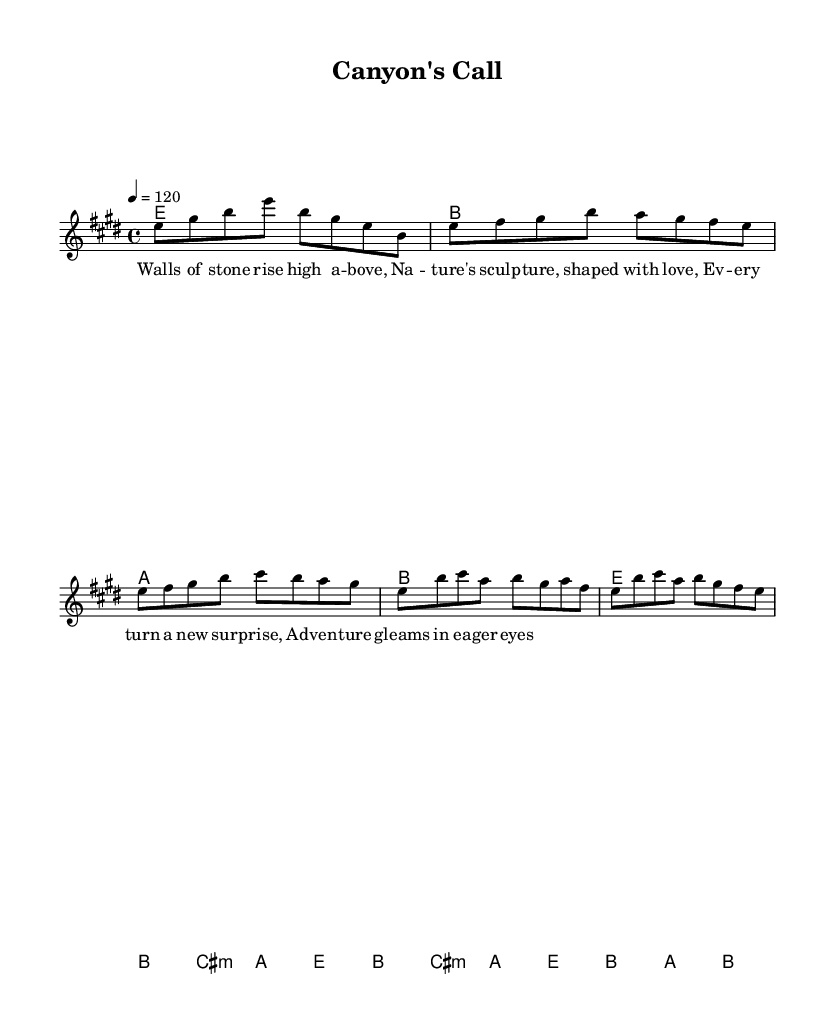What is the key signature of this music? The key signature is E major, which has four sharps (F#, C#, G#, and D#). This is indicated at the beginning of the score.
Answer: E major What is the time signature of this music? The time signature is 4/4, which means there are four beats in a measure, and each beat is a quarter note. This information is clearly stated in the beginning of the sheet music.
Answer: 4/4 What is the tempo marking for this piece? The tempo marking specifies a tempo of 120 beats per minute, as indicated in the score. This is typically denoted by the term "tempo" followed by a number.
Answer: 120 How many measures are in the verse section? Counting the measures notated in the verse section, there are a total of 4 measures present in that portion of the sheet music. Each line corresponds to one measure.
Answer: 4 What is the first chord in the introduction? The first chord in the introduction is E major, which is indicated by the corresponding chord symbol at the beginning of the score and represented in the chord progression.
Answer: E Which lyric line corresponds to the first measure? The first measure corresponds to the lyric line "Walls of stone rise high a -- bove," as the melody aligns with this text in the lyrics section.
Answer: Walls of stone rise high a -- bove What is the last chord of the chorus? The last chord of the chorus is B major, which is represented in the harmonic progression before transitioning to the next section of the song.
Answer: B 